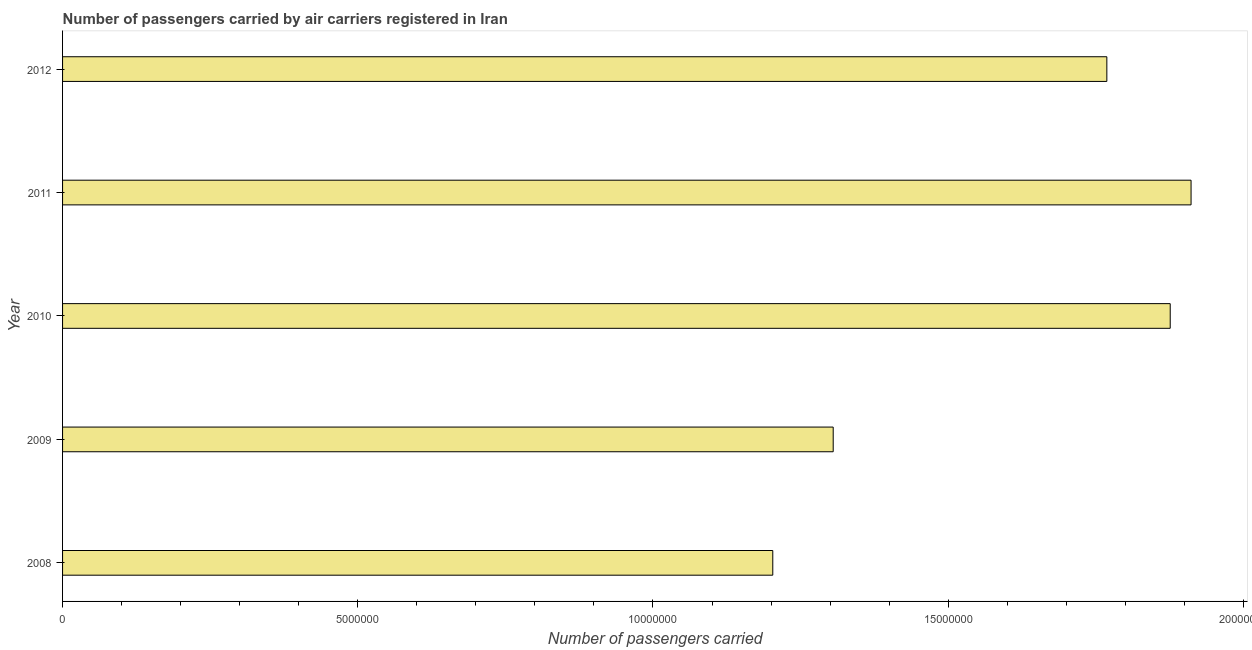What is the title of the graph?
Ensure brevity in your answer.  Number of passengers carried by air carriers registered in Iran. What is the label or title of the X-axis?
Provide a succinct answer. Number of passengers carried. What is the label or title of the Y-axis?
Offer a very short reply. Year. What is the number of passengers carried in 2010?
Offer a very short reply. 1.88e+07. Across all years, what is the maximum number of passengers carried?
Make the answer very short. 1.91e+07. Across all years, what is the minimum number of passengers carried?
Offer a very short reply. 1.20e+07. In which year was the number of passengers carried maximum?
Provide a short and direct response. 2011. What is the sum of the number of passengers carried?
Your response must be concise. 8.06e+07. What is the difference between the number of passengers carried in 2008 and 2011?
Ensure brevity in your answer.  -7.08e+06. What is the average number of passengers carried per year?
Ensure brevity in your answer.  1.61e+07. What is the median number of passengers carried?
Offer a very short reply. 1.77e+07. In how many years, is the number of passengers carried greater than 1000000 ?
Ensure brevity in your answer.  5. What is the ratio of the number of passengers carried in 2009 to that in 2012?
Your response must be concise. 0.74. Is the difference between the number of passengers carried in 2008 and 2009 greater than the difference between any two years?
Offer a terse response. No. What is the difference between the highest and the second highest number of passengers carried?
Your response must be concise. 3.53e+05. Is the sum of the number of passengers carried in 2009 and 2010 greater than the maximum number of passengers carried across all years?
Make the answer very short. Yes. What is the difference between the highest and the lowest number of passengers carried?
Keep it short and to the point. 7.08e+06. What is the Number of passengers carried of 2008?
Offer a terse response. 1.20e+07. What is the Number of passengers carried in 2009?
Your response must be concise. 1.31e+07. What is the Number of passengers carried in 2010?
Give a very brief answer. 1.88e+07. What is the Number of passengers carried of 2011?
Ensure brevity in your answer.  1.91e+07. What is the Number of passengers carried of 2012?
Offer a very short reply. 1.77e+07. What is the difference between the Number of passengers carried in 2008 and 2009?
Keep it short and to the point. -1.02e+06. What is the difference between the Number of passengers carried in 2008 and 2010?
Your answer should be compact. -6.73e+06. What is the difference between the Number of passengers carried in 2008 and 2011?
Provide a succinct answer. -7.08e+06. What is the difference between the Number of passengers carried in 2008 and 2012?
Ensure brevity in your answer.  -5.66e+06. What is the difference between the Number of passengers carried in 2009 and 2010?
Your response must be concise. -5.71e+06. What is the difference between the Number of passengers carried in 2009 and 2011?
Give a very brief answer. -6.06e+06. What is the difference between the Number of passengers carried in 2009 and 2012?
Ensure brevity in your answer.  -4.63e+06. What is the difference between the Number of passengers carried in 2010 and 2011?
Give a very brief answer. -3.53e+05. What is the difference between the Number of passengers carried in 2010 and 2012?
Your answer should be very brief. 1.07e+06. What is the difference between the Number of passengers carried in 2011 and 2012?
Keep it short and to the point. 1.43e+06. What is the ratio of the Number of passengers carried in 2008 to that in 2009?
Your answer should be very brief. 0.92. What is the ratio of the Number of passengers carried in 2008 to that in 2010?
Your response must be concise. 0.64. What is the ratio of the Number of passengers carried in 2008 to that in 2011?
Provide a short and direct response. 0.63. What is the ratio of the Number of passengers carried in 2008 to that in 2012?
Ensure brevity in your answer.  0.68. What is the ratio of the Number of passengers carried in 2009 to that in 2010?
Make the answer very short. 0.7. What is the ratio of the Number of passengers carried in 2009 to that in 2011?
Keep it short and to the point. 0.68. What is the ratio of the Number of passengers carried in 2009 to that in 2012?
Keep it short and to the point. 0.74. What is the ratio of the Number of passengers carried in 2010 to that in 2011?
Your response must be concise. 0.98. What is the ratio of the Number of passengers carried in 2010 to that in 2012?
Offer a terse response. 1.06. What is the ratio of the Number of passengers carried in 2011 to that in 2012?
Your answer should be compact. 1.08. 